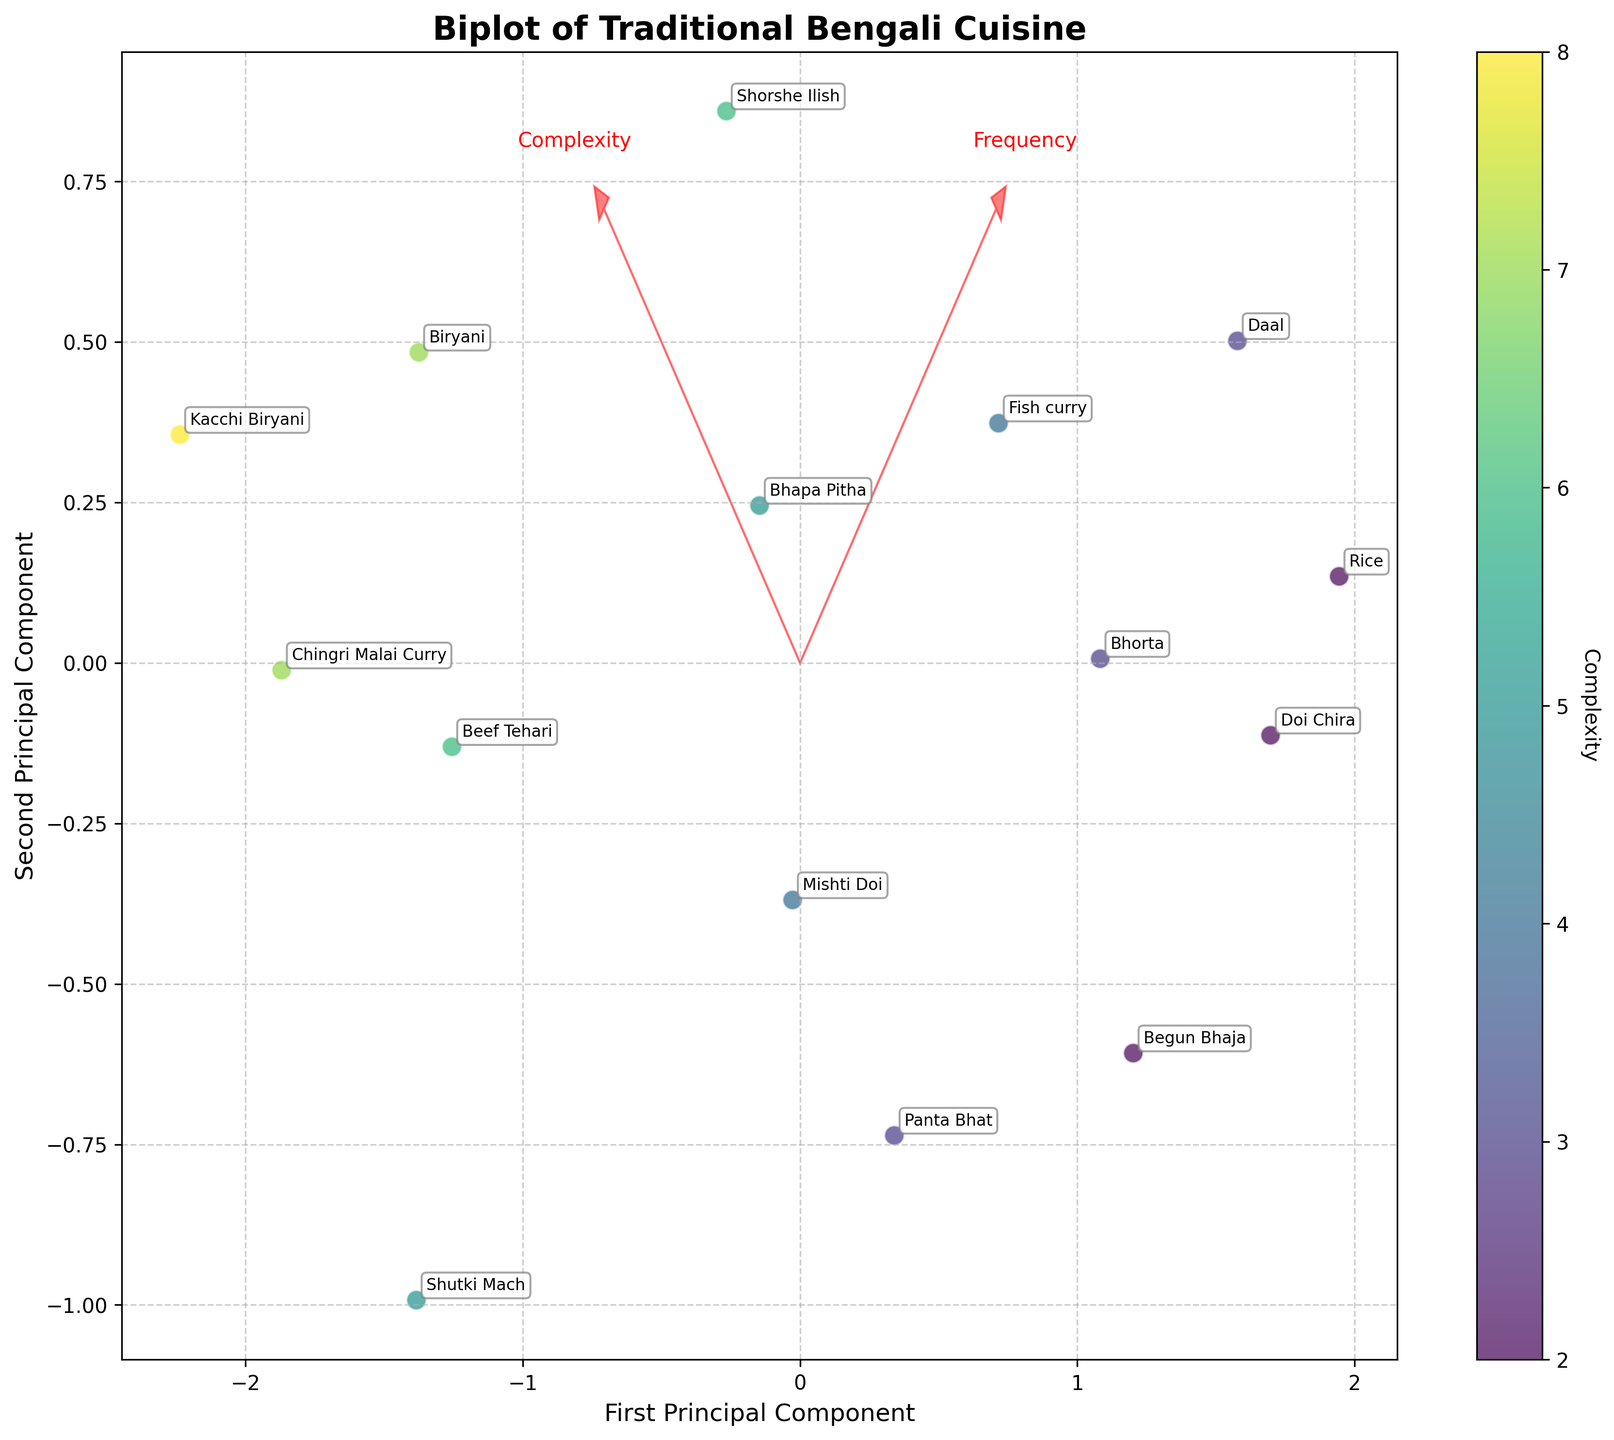What is the title of the biplot? The title is present at the top of the plot, typically in larger font size and bold for emphasis.
Answer: Biplot of Traditional Bengali Cuisine How many principal components are displayed in the plot? The plot shows two axes labeled as the First Principal Component and the Second Principal Component, indicating that there are two principal components.
Answer: Two Which region has the highest complexity for its cuisine? The colors of the data points represent complexity. The darkest points represent higher complexities. We can see that the data point "Kacchi Biryani" from Dhaka has the highest complexity value labeled as 8.
Answer: Dhaka (Kacchi Biryani) What is the relationship between 'Frequency' and 'Complexity' as depicted in the biplot? Arrows represent feature vectors, indicating the correlation between 'Frequency' and 'Complexity'. The angle between the 'Frequency' and 'Complexity' arrows can show if they are correlated. Here, they are almost orthogonal, suggesting minimal correlation.
Answer: Minimal correlation Which ingredient falls closest to the origin in the biplot? The point closest to the intersection of the axes (the origin) is the one with coordinates closest to (0,0). "Shutki Mach" is the ingredient closest to the origin.
Answer: Shutki Mach Which ingredient has the highest frequency? Observing the scatter plot and noting the labels, the point farthest in the direction of the 'Frequency' arrow would have the highest frequency. "Rice" is placed at the higher end of the 'Frequency' vector.
Answer: Rice How are "Frequency" and "Complexity" annotated on the plot? Annotations are shown using red arrows with text labels placed a little farther from the arrowheads.
Answer: With red arrows and text labels Compare "Rice" and "Bhapa Pitha" in terms of their positions on the principal components. "Rice" and "Bhapa Pitha" are plotted on the scatter plot. Rice is higher on the first principal component while Bhapa Pitha is lower on the second principal component.
Answer: Rice is higher on PC1, Bhapa Pitha is lower on PC2 Which preparation method has the least complexity and where is it from? The lighter the color of the data point, the lower the complexity. The point “Begun Bhaja” has a lighter shade, indicating it is from Nationwide and has a Preparation method of Frying.
Answer: Frying from Nationwide Which socioeconomic group is associated with the most complex ingredient? The data point "Kacchi Biryani" from Dhaka (Upper class) has a complexity labeled as 8, which is the highest in the dataset.
Answer: Upper class 